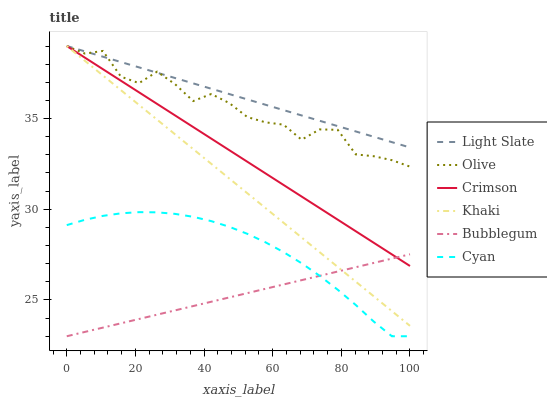Does Bubblegum have the minimum area under the curve?
Answer yes or no. Yes. Does Light Slate have the maximum area under the curve?
Answer yes or no. Yes. Does Light Slate have the minimum area under the curve?
Answer yes or no. No. Does Bubblegum have the maximum area under the curve?
Answer yes or no. No. Is Light Slate the smoothest?
Answer yes or no. Yes. Is Olive the roughest?
Answer yes or no. Yes. Is Bubblegum the smoothest?
Answer yes or no. No. Is Bubblegum the roughest?
Answer yes or no. No. Does Bubblegum have the lowest value?
Answer yes or no. Yes. Does Light Slate have the lowest value?
Answer yes or no. No. Does Olive have the highest value?
Answer yes or no. Yes. Does Bubblegum have the highest value?
Answer yes or no. No. Is Cyan less than Khaki?
Answer yes or no. Yes. Is Khaki greater than Cyan?
Answer yes or no. Yes. Does Bubblegum intersect Khaki?
Answer yes or no. Yes. Is Bubblegum less than Khaki?
Answer yes or no. No. Is Bubblegum greater than Khaki?
Answer yes or no. No. Does Cyan intersect Khaki?
Answer yes or no. No. 